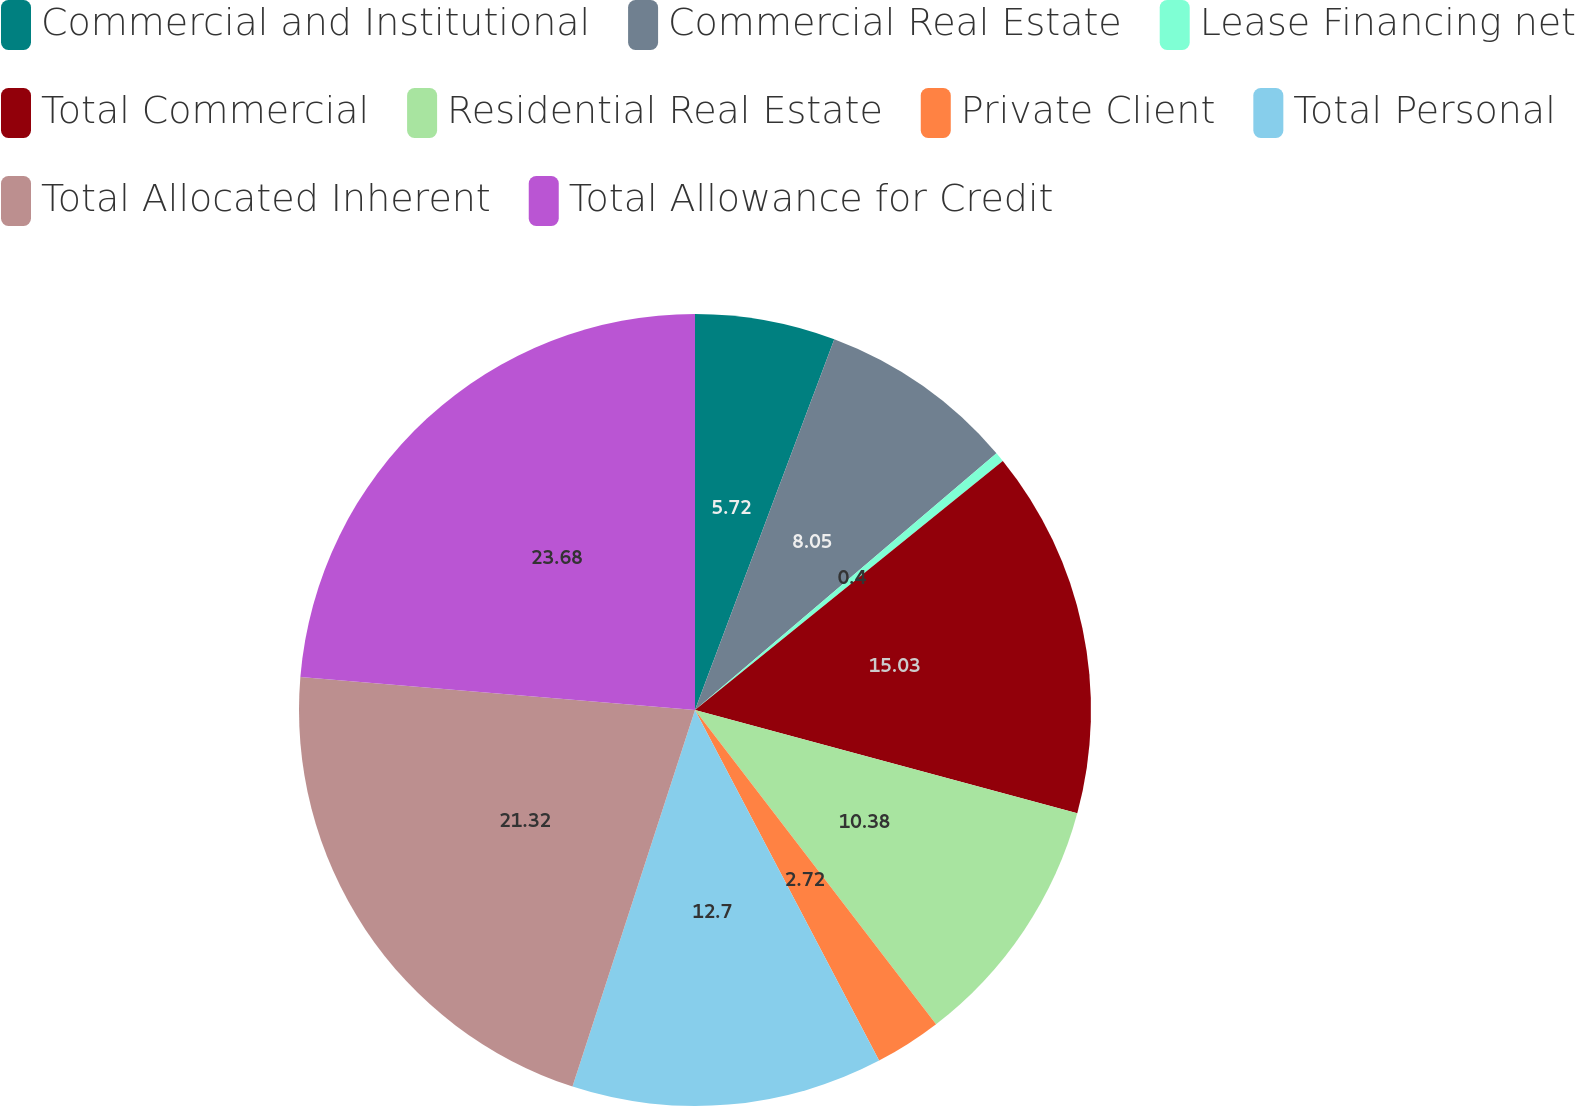Convert chart to OTSL. <chart><loc_0><loc_0><loc_500><loc_500><pie_chart><fcel>Commercial and Institutional<fcel>Commercial Real Estate<fcel>Lease Financing net<fcel>Total Commercial<fcel>Residential Real Estate<fcel>Private Client<fcel>Total Personal<fcel>Total Allocated Inherent<fcel>Total Allowance for Credit<nl><fcel>5.72%<fcel>8.05%<fcel>0.4%<fcel>15.03%<fcel>10.38%<fcel>2.72%<fcel>12.7%<fcel>21.32%<fcel>23.67%<nl></chart> 